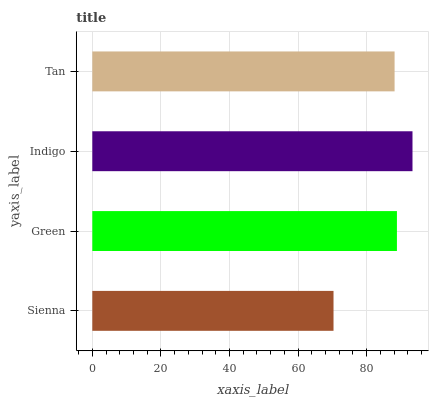Is Sienna the minimum?
Answer yes or no. Yes. Is Indigo the maximum?
Answer yes or no. Yes. Is Green the minimum?
Answer yes or no. No. Is Green the maximum?
Answer yes or no. No. Is Green greater than Sienna?
Answer yes or no. Yes. Is Sienna less than Green?
Answer yes or no. Yes. Is Sienna greater than Green?
Answer yes or no. No. Is Green less than Sienna?
Answer yes or no. No. Is Green the high median?
Answer yes or no. Yes. Is Tan the low median?
Answer yes or no. Yes. Is Sienna the high median?
Answer yes or no. No. Is Indigo the low median?
Answer yes or no. No. 